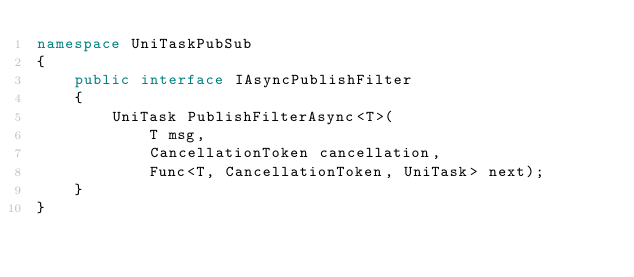<code> <loc_0><loc_0><loc_500><loc_500><_C#_>namespace UniTaskPubSub
{
    public interface IAsyncPublishFilter
    {
        UniTask PublishFilterAsync<T>(
            T msg,
            CancellationToken cancellation,
            Func<T, CancellationToken, UniTask> next);
    }
}
</code> 